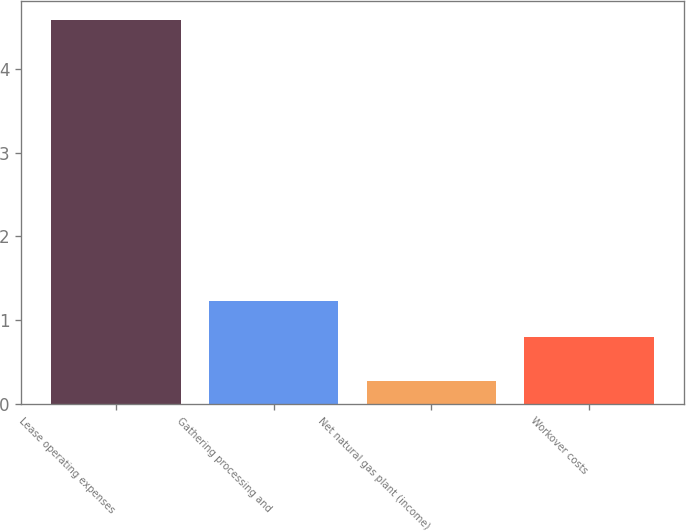<chart> <loc_0><loc_0><loc_500><loc_500><bar_chart><fcel>Lease operating expenses<fcel>Gathering processing and<fcel>Net natural gas plant (income)<fcel>Workover costs<nl><fcel>4.58<fcel>1.23<fcel>0.28<fcel>0.8<nl></chart> 